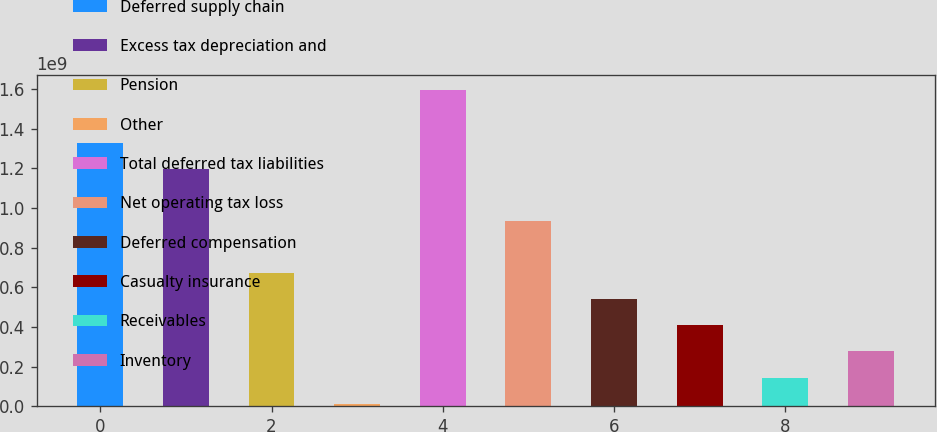Convert chart to OTSL. <chart><loc_0><loc_0><loc_500><loc_500><bar_chart><fcel>Deferred supply chain<fcel>Excess tax depreciation and<fcel>Pension<fcel>Other<fcel>Total deferred tax liabilities<fcel>Net operating tax loss<fcel>Deferred compensation<fcel>Casualty insurance<fcel>Receivables<fcel>Inventory<nl><fcel>1.32913e+09<fcel>1.1976e+09<fcel>6.71498e+08<fcel>1.3864e+07<fcel>1.59218e+09<fcel>9.34551e+08<fcel>5.39971e+08<fcel>4.08444e+08<fcel>1.45391e+08<fcel>2.76917e+08<nl></chart> 